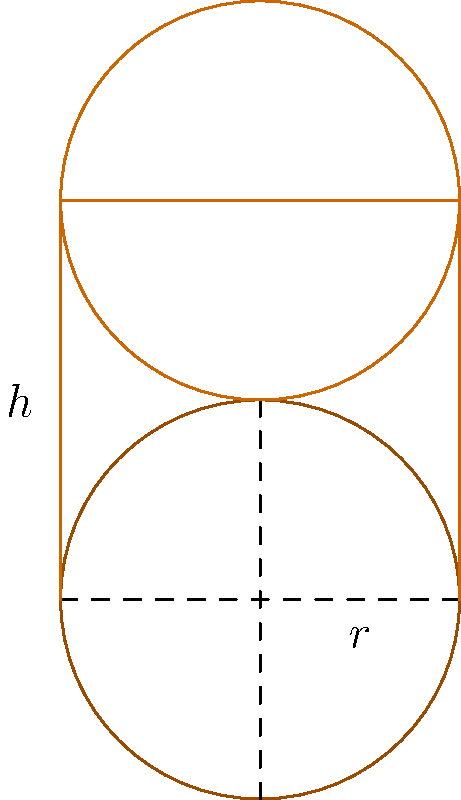In your study of Aztec musical instruments, you've come across a cylindrical drum with a radius of 20 cm and a height of 60 cm. Using the formula for the volume of a cylinder, $V = \pi r^2 h$, where $r$ is the radius of the base and $h$ is the height, calculate the volume of this drum in cubic centimeters. Round your answer to the nearest whole number. To solve this problem, we'll follow these steps:

1. Identify the given information:
   - Radius ($r$) = 20 cm
   - Height ($h$) = 60 cm

2. Recall the formula for the volume of a cylinder:
   $V = \pi r^2 h$

3. Substitute the values into the formula:
   $V = \pi \cdot (20 \text{ cm})^2 \cdot 60 \text{ cm}$

4. Calculate the square of the radius:
   $V = \pi \cdot 400 \text{ cm}^2 \cdot 60 \text{ cm}$

5. Multiply the values:
   $V = 24000\pi \text{ cm}^3$

6. Use 3.14159 as an approximation for $\pi$:
   $V \approx 24000 \cdot 3.14159 \text{ cm}^3$
   $V \approx 75398.16 \text{ cm}^3$

7. Round to the nearest whole number:
   $V \approx 75398 \text{ cm}^3$

Therefore, the volume of the Aztec drum is approximately 75398 cubic centimeters.
Answer: 75398 cm³ 